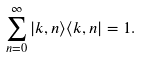<formula> <loc_0><loc_0><loc_500><loc_500>\sum _ { n = 0 } ^ { \infty } | k , n \rangle \langle k , n | = 1 .</formula> 